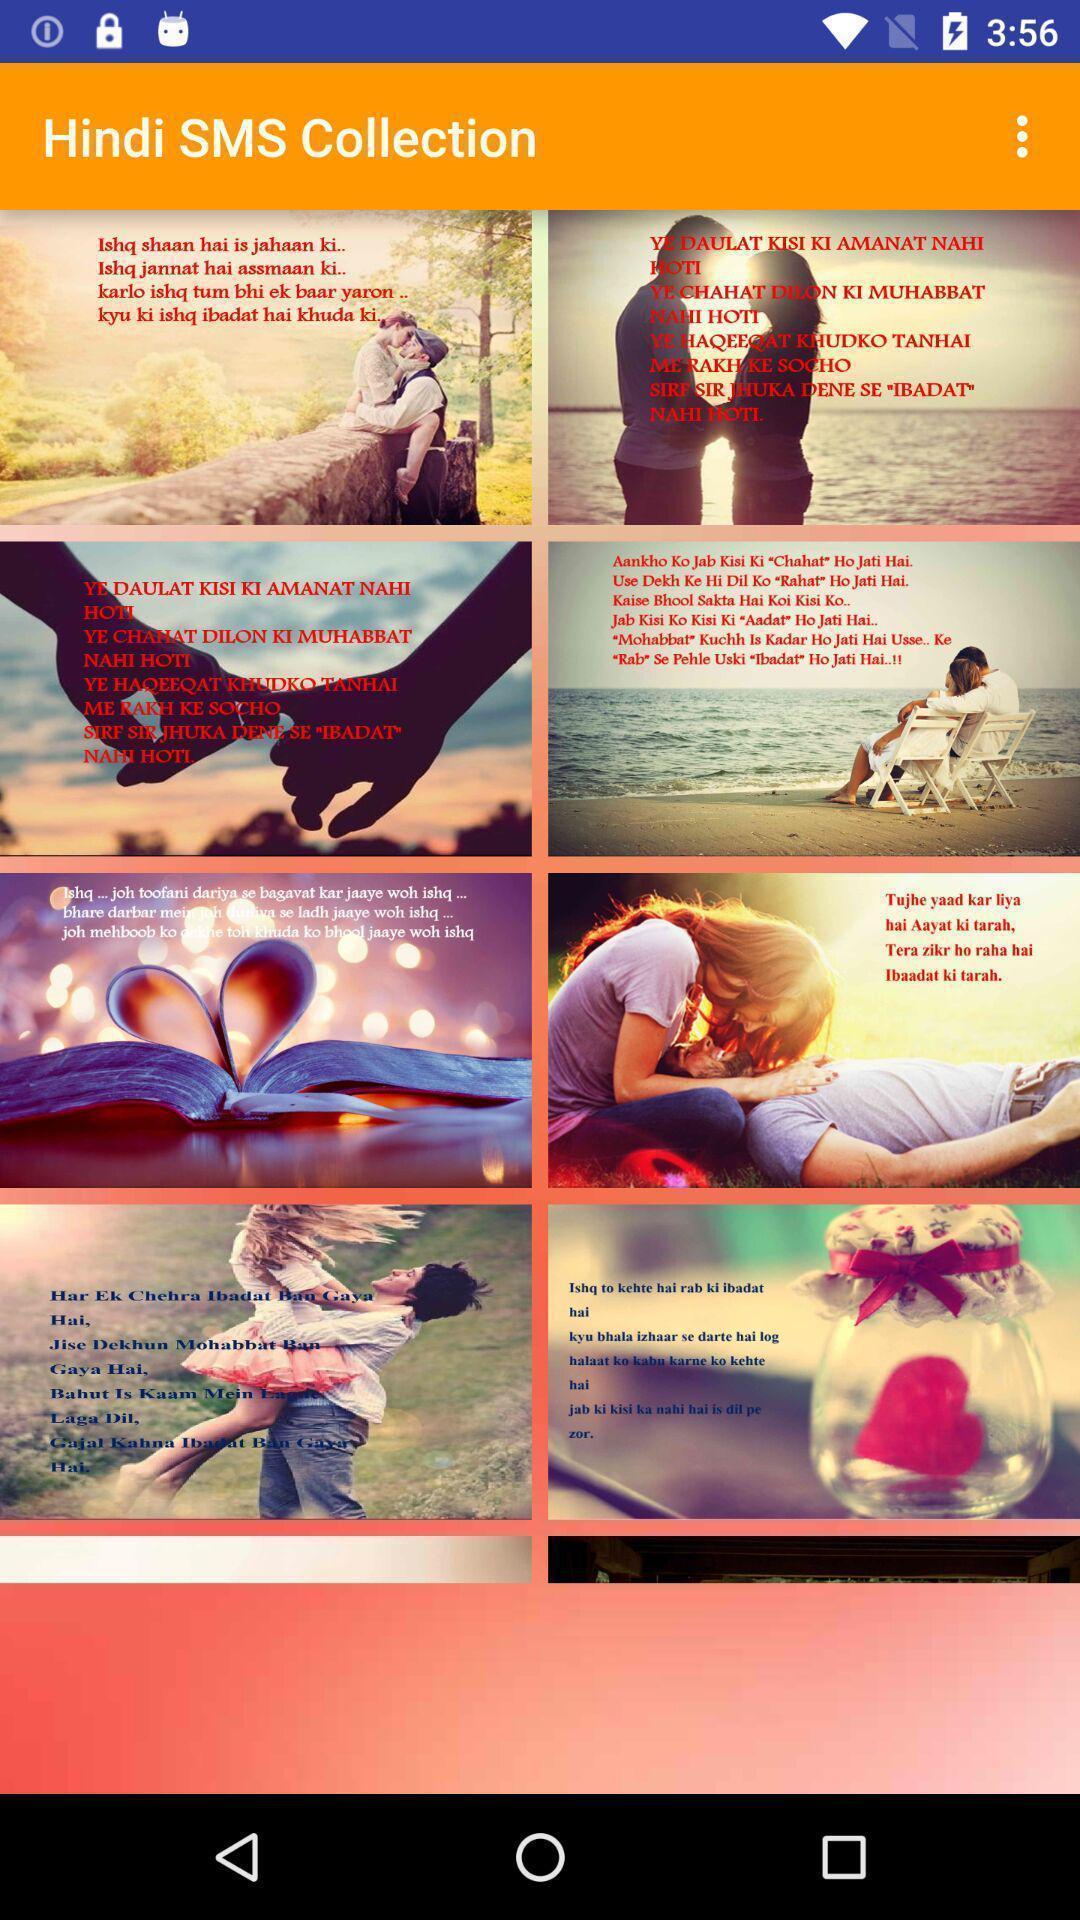Summarize the main components in this picture. Page displaying menu of communication app. 